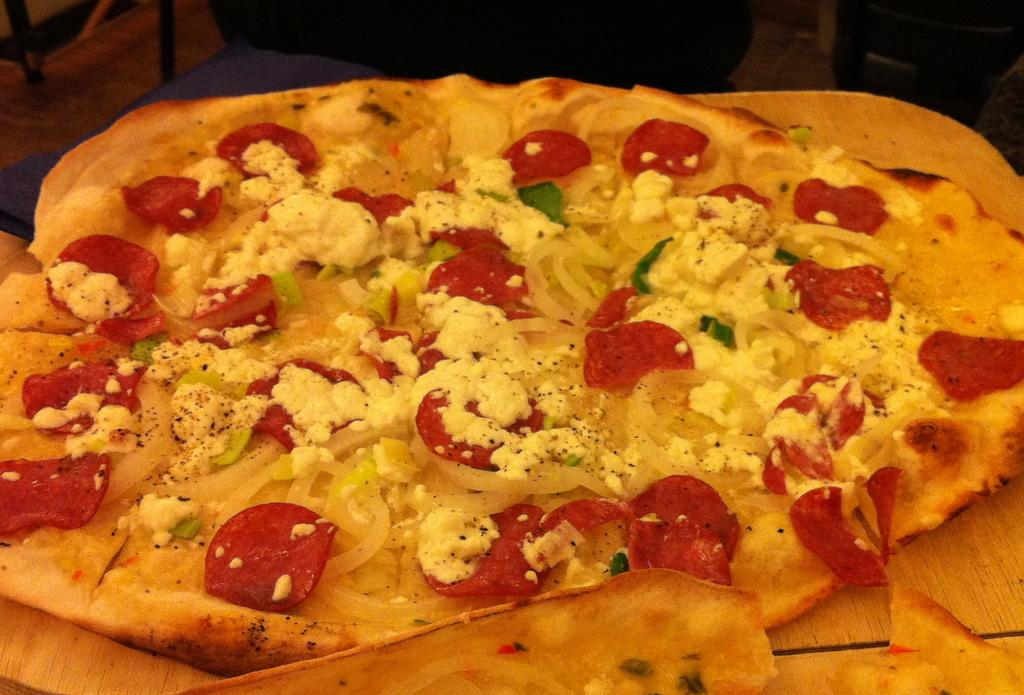What is the main subject in the foreground of the image? There is a pizza in the foreground of the image. What is the pizza placed on? The pizza is on a wooden surface. What can be seen in the background of the image? There is a chair in the background of the image. Where is the chair located in the image? The chair is in the left top corner of the image. What type of beef is being served with the pizza in the image? There is no beef present in the image; it only features a pizza on a wooden surface. Can you tell me how many basketballs are visible in the image? There are no basketballs present in the image. 